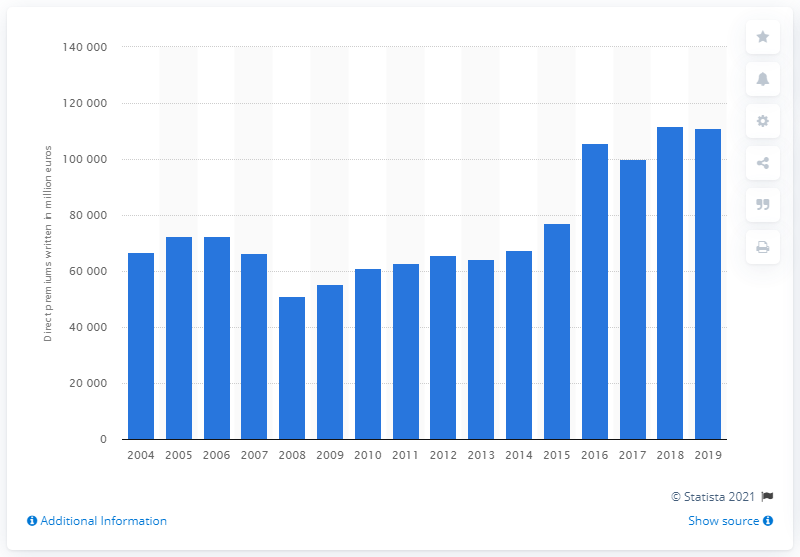Mention a couple of crucial points in this snapshot. The premiums written in 2019 were 110,924. 